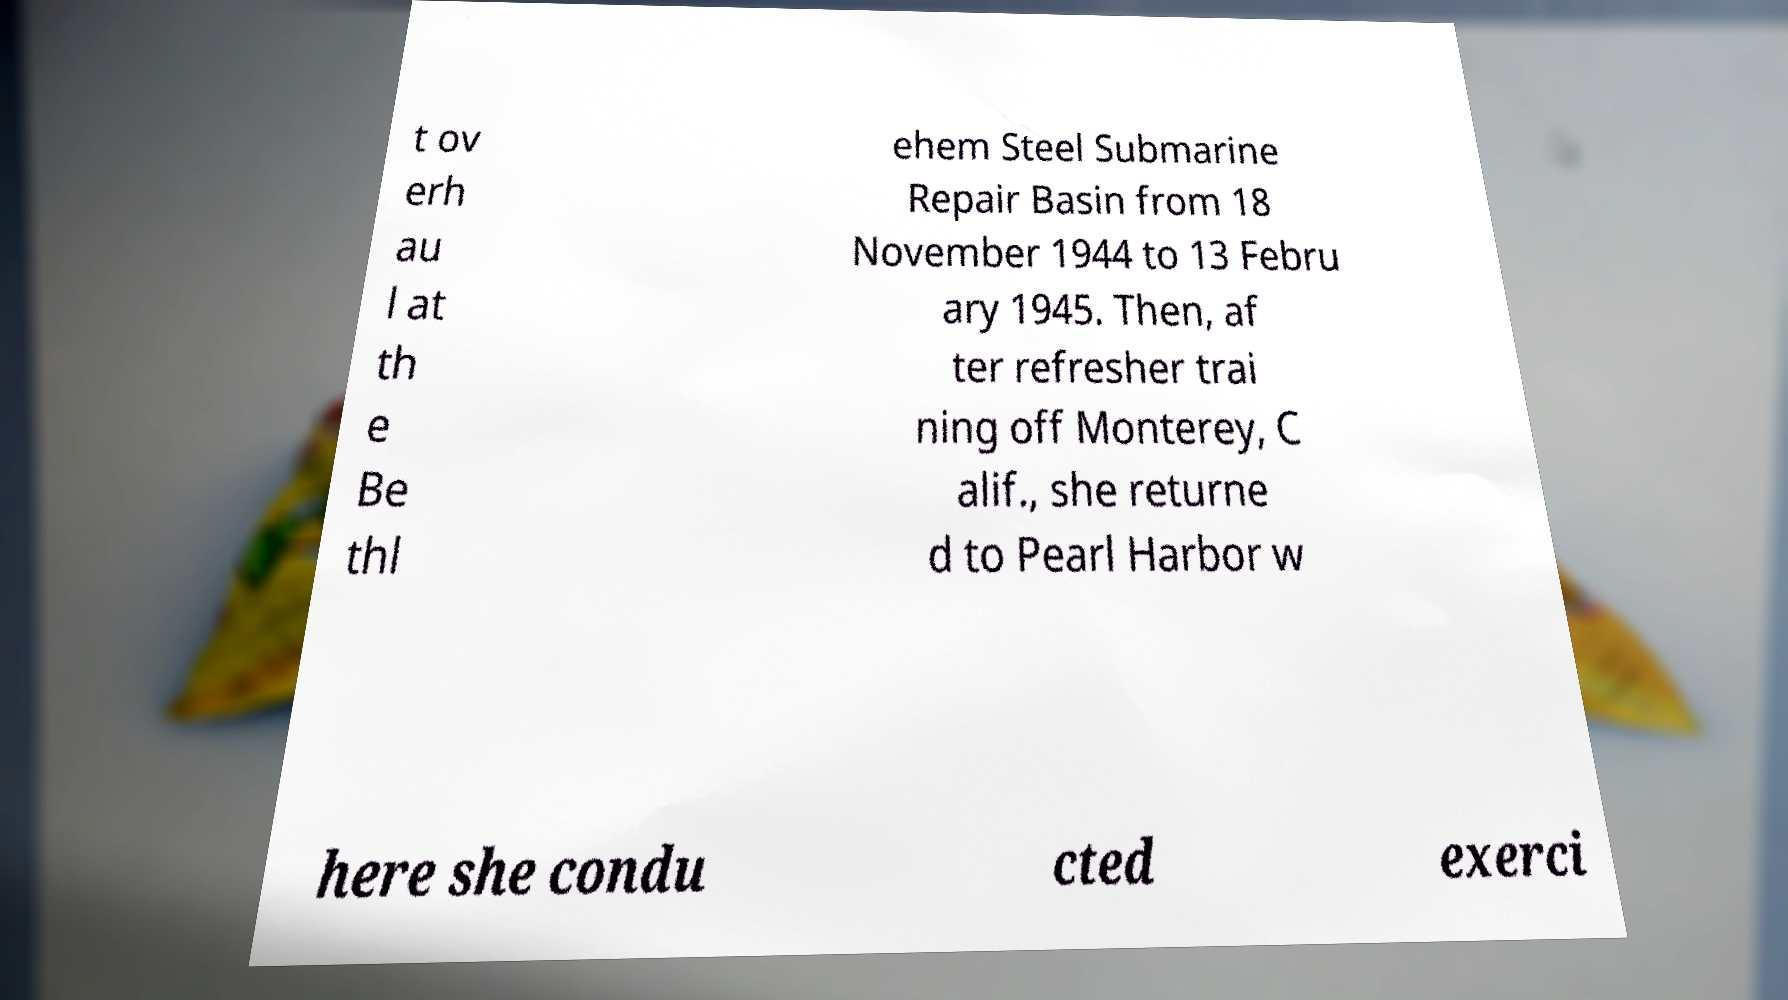Can you read and provide the text displayed in the image?This photo seems to have some interesting text. Can you extract and type it out for me? t ov erh au l at th e Be thl ehem Steel Submarine Repair Basin from 18 November 1944 to 13 Febru ary 1945. Then, af ter refresher trai ning off Monterey, C alif., she returne d to Pearl Harbor w here she condu cted exerci 